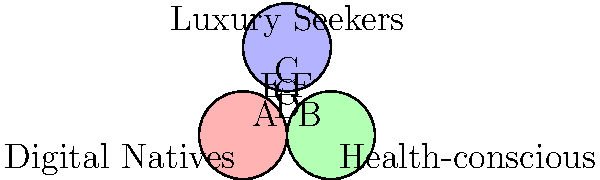In a recent market analysis for a new smartwatch product, you identified three key customer segments: Digital Natives, Health-conscious consumers, and Luxury Seekers. The Venn diagram above represents the overlap between these segments. If the total market size is 10,000 potential customers, and segment A (exclusive Digital Natives) represents 15% of the total market, while segment G (overlap of all three segments) represents 5% of the total market, what is the minimum percentage of the market that your product must appeal to in order to reach at least half of the total market? To solve this problem, we need to follow these steps:

1. Identify the given information:
   - Total market size: 10,000 customers
   - Segment A (exclusive Digital Natives): 15% of the total market
   - Segment G (overlap of all three segments): 5% of the total market
   - Goal: Reach at least half of the total market

2. Calculate the number of customers in segments A and G:
   - Segment A: $15\% \times 10,000 = 1,500$ customers
   - Segment G: $5\% \times 10,000 = 500$ customers

3. Determine the minimum number of customers needed to reach half the market:
   - Half of the market: $50\% \times 10,000 = 5,000$ customers

4. Consider the most efficient way to reach the target:
   - Start with segment G, as it appeals to all three customer groups
   - Then add segment A, which is the largest exclusive segment given

5. Calculate the total customers reached by targeting G and A:
   - Customers reached: $500 + 1,500 = 2,000$

6. Calculate the remaining customers needed:
   - Remaining: $5,000 - 2,000 = 3,000$ customers

7. Determine the minimum additional percentage needed:
   - Additional percentage: $(3,000 \div 10,000) \times 100 = 30\%$

8. Calculate the total minimum percentage:
   - Total minimum percentage: $5\% + 15\% + 30\% = 50\%$

Therefore, the product must appeal to at least 50% of the market to reach half of the total market size.
Answer: 50% 